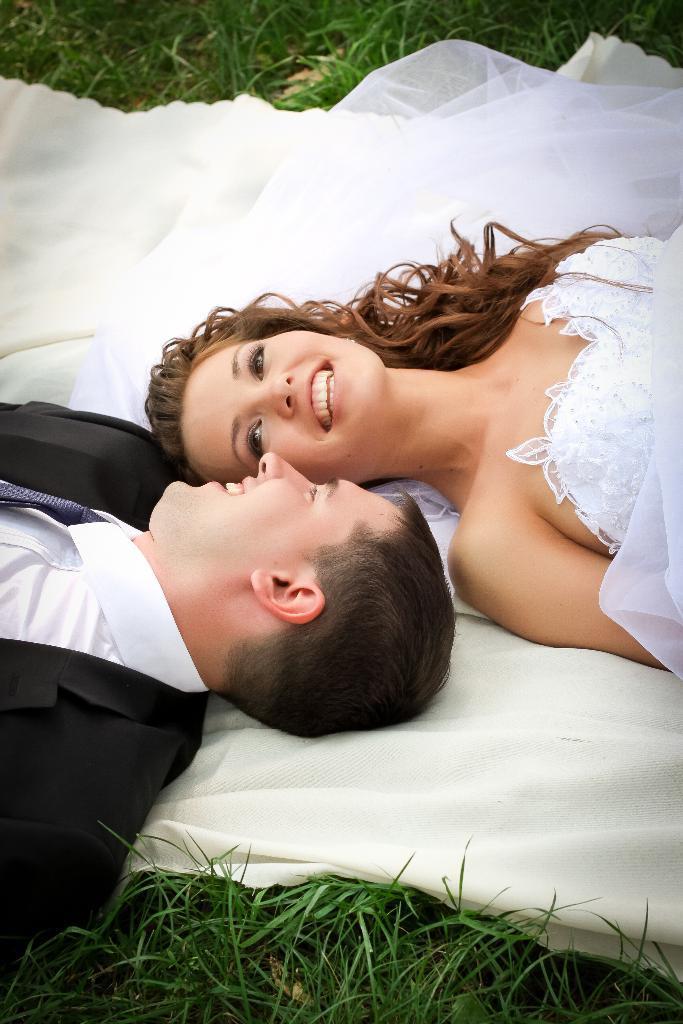Can you describe this image briefly? In this image we can see two persons lying on a cloth. Beside the cloth we can see the grass. 